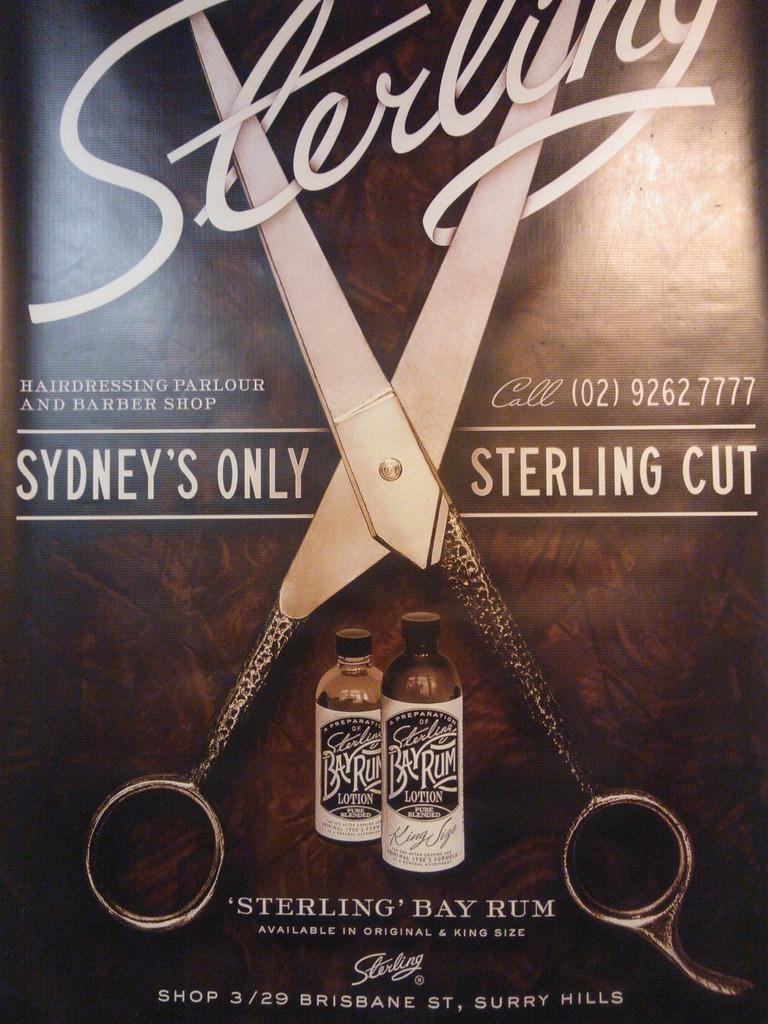<image>
Provide a brief description of the given image. An advertisement for Sterling Bay Rum depicting an open scissor in the middle of the advertisement. 